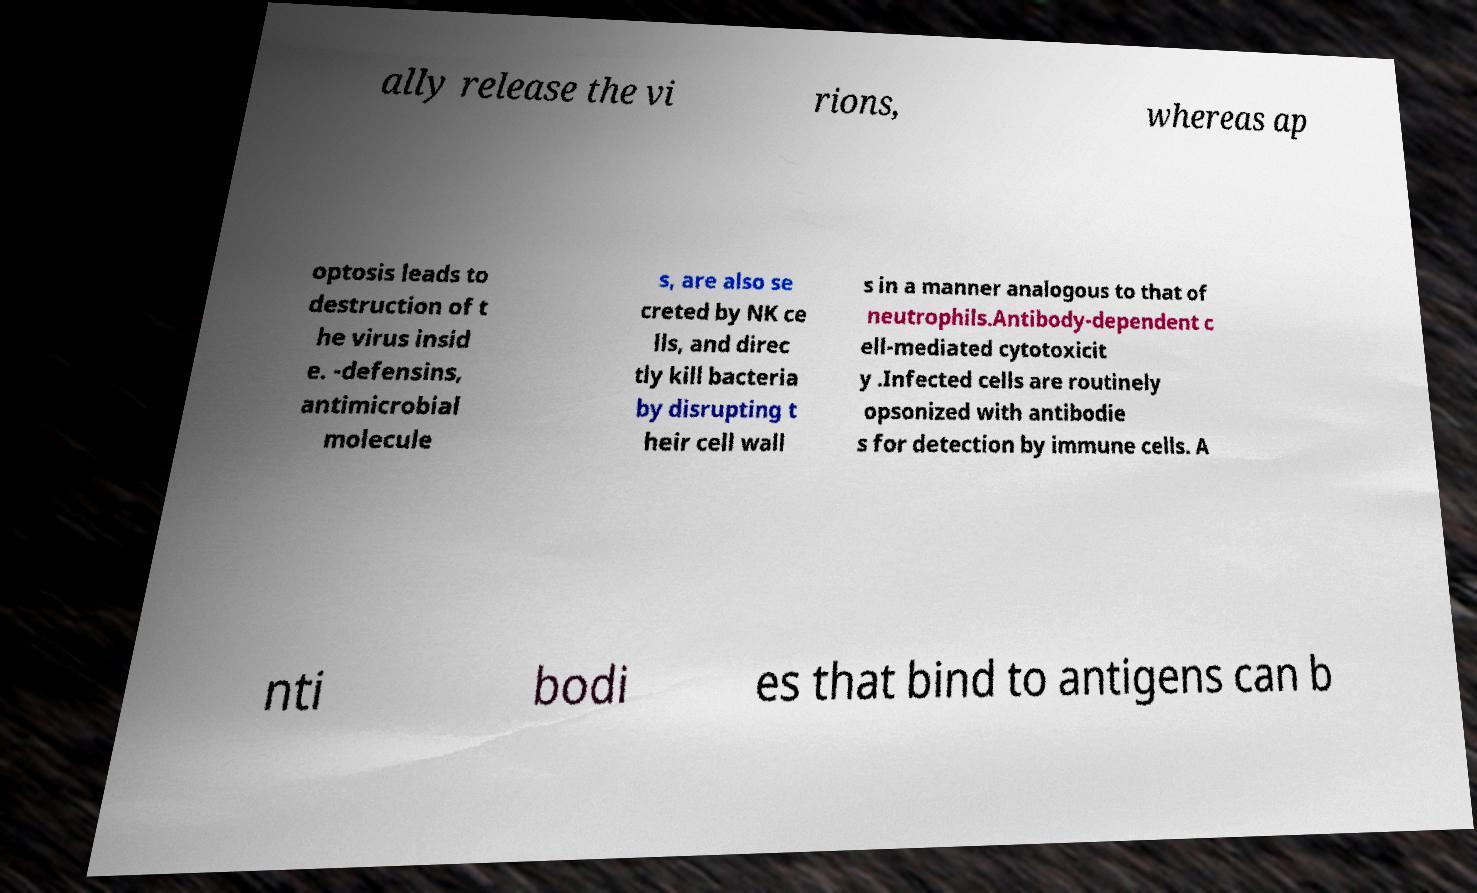I need the written content from this picture converted into text. Can you do that? ally release the vi rions, whereas ap optosis leads to destruction of t he virus insid e. -defensins, antimicrobial molecule s, are also se creted by NK ce lls, and direc tly kill bacteria by disrupting t heir cell wall s in a manner analogous to that of neutrophils.Antibody-dependent c ell-mediated cytotoxicit y .Infected cells are routinely opsonized with antibodie s for detection by immune cells. A nti bodi es that bind to antigens can b 